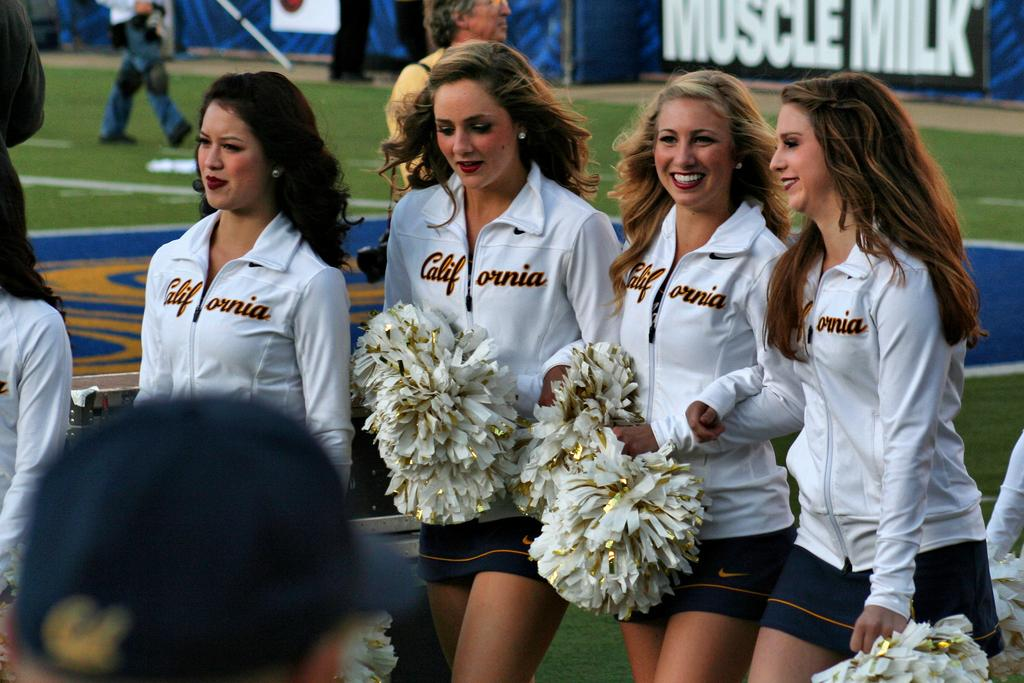<image>
Relay a brief, clear account of the picture shown. a few cheerleaders with a Muscle Milk ad in the background 